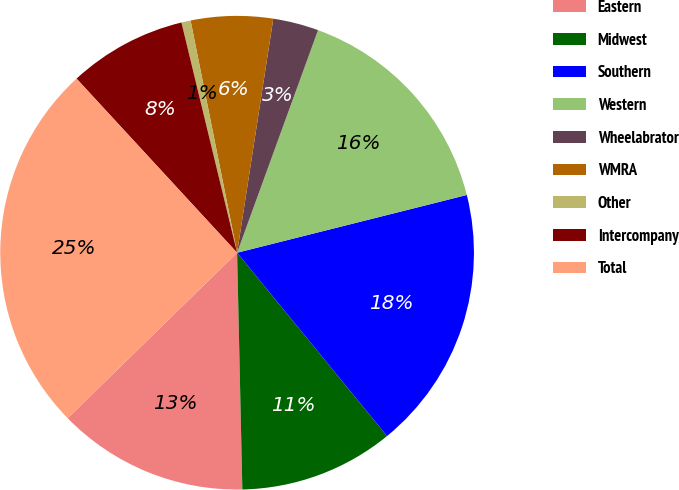Convert chart to OTSL. <chart><loc_0><loc_0><loc_500><loc_500><pie_chart><fcel>Eastern<fcel>Midwest<fcel>Southern<fcel>Western<fcel>Wheelabrator<fcel>WMRA<fcel>Other<fcel>Intercompany<fcel>Total<nl><fcel>13.04%<fcel>10.56%<fcel>18.01%<fcel>15.53%<fcel>3.11%<fcel>5.59%<fcel>0.63%<fcel>8.08%<fcel>25.46%<nl></chart> 